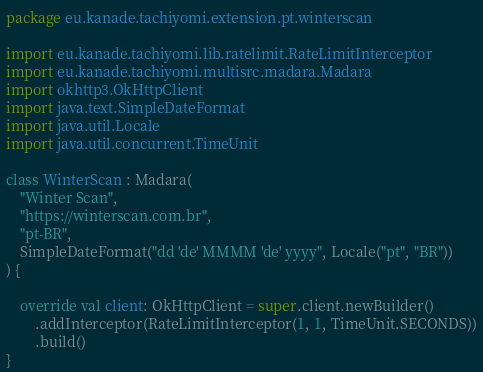<code> <loc_0><loc_0><loc_500><loc_500><_Kotlin_>package eu.kanade.tachiyomi.extension.pt.winterscan

import eu.kanade.tachiyomi.lib.ratelimit.RateLimitInterceptor
import eu.kanade.tachiyomi.multisrc.madara.Madara
import okhttp3.OkHttpClient
import java.text.SimpleDateFormat
import java.util.Locale
import java.util.concurrent.TimeUnit

class WinterScan : Madara(
    "Winter Scan",
    "https://winterscan.com.br",
    "pt-BR",
    SimpleDateFormat("dd 'de' MMMM 'de' yyyy", Locale("pt", "BR"))
) {

    override val client: OkHttpClient = super.client.newBuilder()
        .addInterceptor(RateLimitInterceptor(1, 1, TimeUnit.SECONDS))
        .build()
}
</code> 